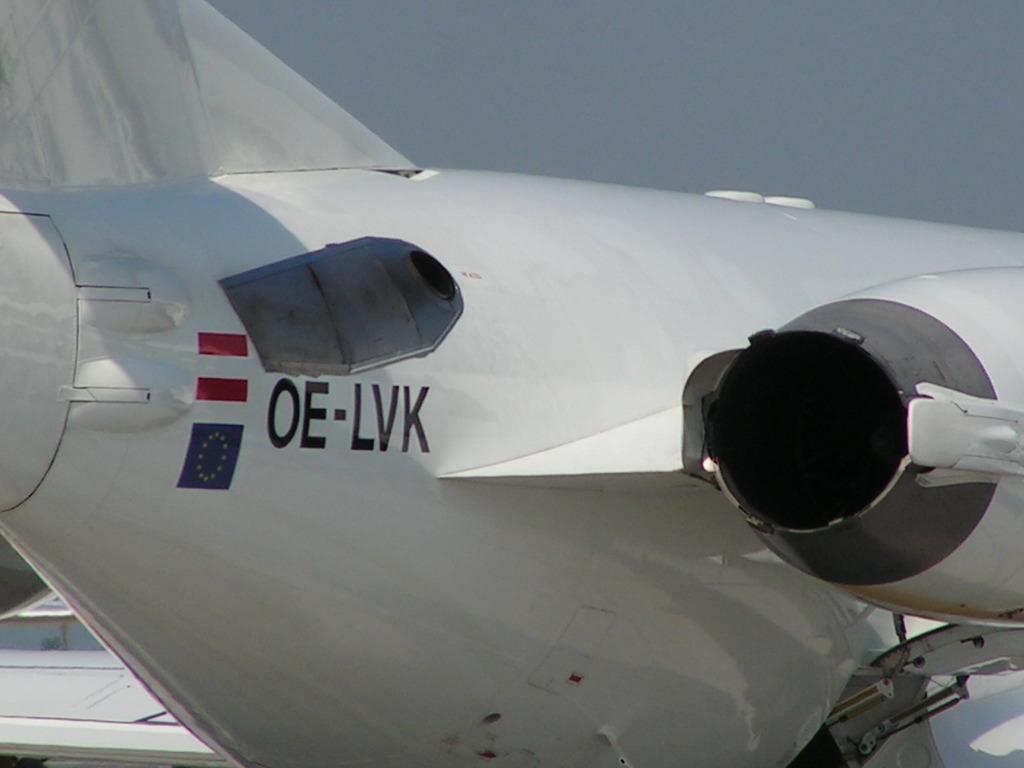Provide a one-sentence caption for the provided image. A white airplane with the letters OE-LVK and a flag. 